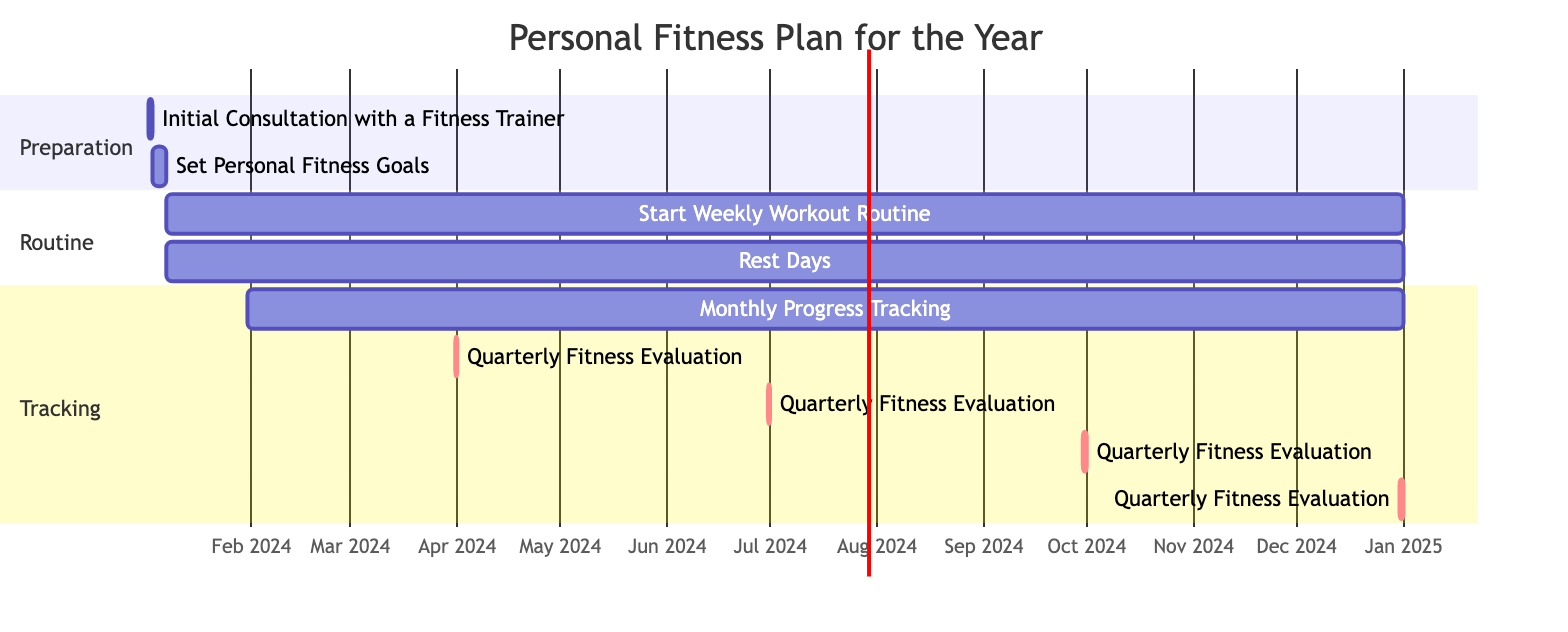What is the duration of the "Set Personal Fitness Goals" task? The duration of the "Set Personal Fitness Goals" task is explicitly mentioned as 4 days in the data provided.
Answer: 4 days What task starts on January 31, 2024? Based on the diagram, the task that begins on January 31, 2024, is "Monthly Progress Tracking," which is listed in the tracking section.
Answer: Monthly Progress Tracking How many quarterly fitness evaluations are scheduled for the year? The diagram shows that there are four instances of "Quarterly Fitness Evaluation," each occurring at the end of a quarter.
Answer: 4 Which task overlaps with the "Start Weekly Workout Routine"? The "Rest Days" task overlaps with the "Start Weekly Workout Routine," as both tasks start on the same date, January 7, 2024, and continue throughout the year.
Answer: Rest Days What is the end date of the "Initial Consultation with a Fitness Trainer" task? The end date for the "Initial Consultation with a Fitness Trainer" task is specified as January 2, 2024, as it is a single-day task.
Answer: January 2, 2024 Which section includes the "Quarterly Fitness Evaluation"? The "Quarterly Fitness Evaluation" tasks are situated in the "Tracking" section of the diagram, indicating that they are part of the monitoring and evaluation phase of the fitness plan.
Answer: Tracking What is the total duration of the "Start Weekly Workout Routine"? The total duration of the "Start Weekly Workout Routine" is 360 days, as stated in the data, indicating it is a year-long routine from its start date.
Answer: 360 days What is the time gap between the "Initial Consultation with a Fitness Trainer" and "Set Personal Fitness Goals"? The "Set Personal Fitness Goals" starts the day after the "Initial Consultation," resulting in a gap of 1 day.
Answer: 1 day 